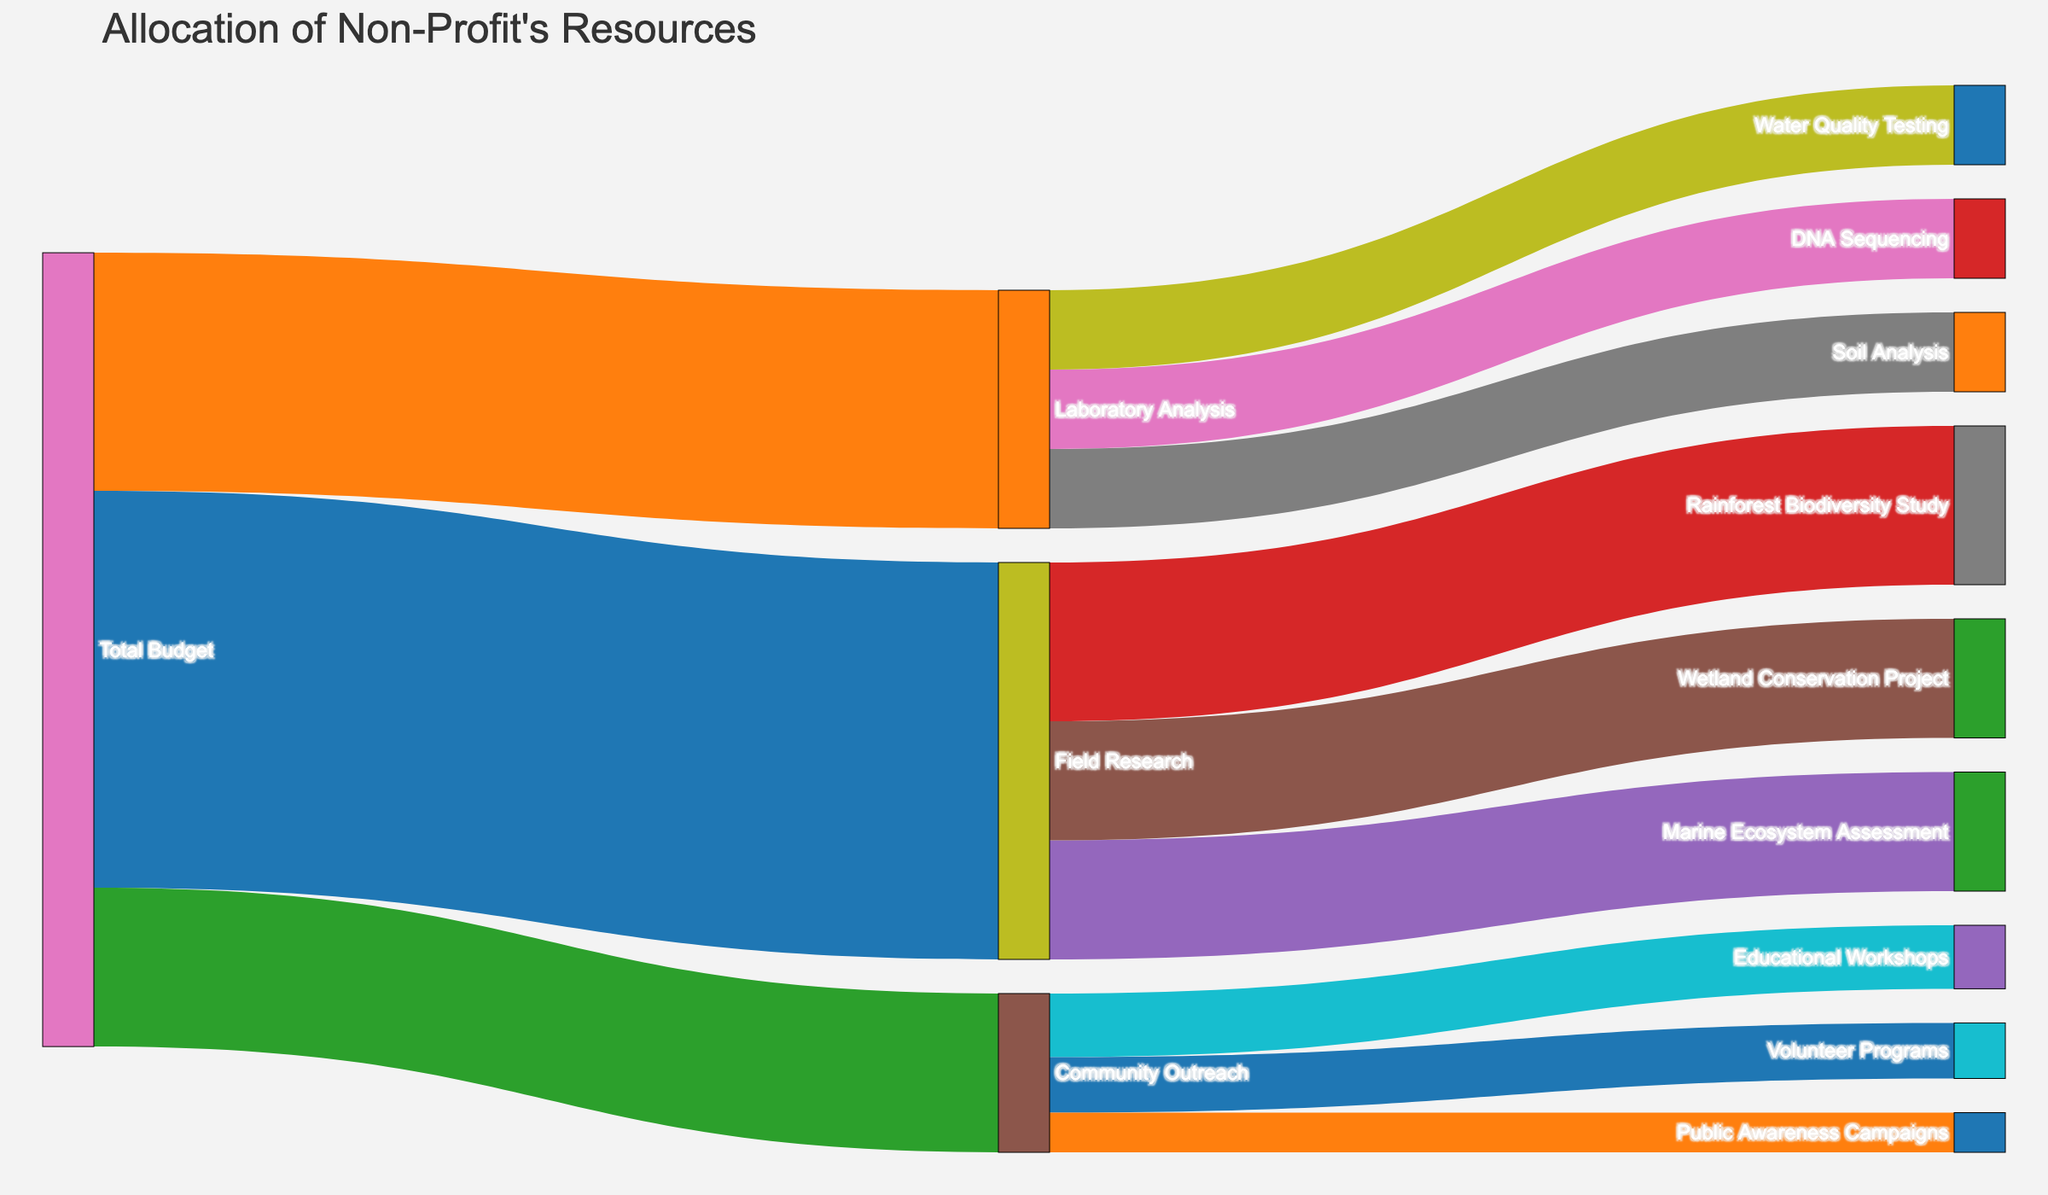What is the total budget allocated for field research? The figure shows that "Field Research" receives a portion of the "Total Budget." According to the diagram, the allocation for "Field Research" is 500,000.
Answer: 500,000 How much of the total budget is spent on Educational Workshops under Community Outreach? In the Sankey Diagram, under "Community Outreach," the stream leading to "Educational Workshops" is labeled with 80,000.
Answer: 80,000 Which initiative receives the highest funding within Field Research? The figure displays the breakdown under "Field Research." The streams from "Field Research" show "Rainforest Biodiversity Study" receives the highest funding of 200,000.
Answer: Rainforest Biodiversity Study How does the funding for Volunteer Programs compare to Public Awareness Campaigns within Community Outreach? Within "Community Outreach," the diagram shows that "Volunteer Programs" receive 70,000, while "Public Awareness Campaigns" receive 50,000.
Answer: Volunteer Programs receive 20,000 more What is the total amount allocated to community outreach programs? The sum of the streams under "Community Outreach" is the total allocation. Adding up for "Educational Workshops" (80,000), "Volunteer Programs" (70,000), and "Public Awareness Campaigns" (50,000) gives a total of 200,000.
Answer: 200,000 Which area of Laboratory Analysis receives the least funding? The Sankey Diagram indicates that DNA Sequencing, Soil Analysis, and Water Quality Testing each receive 100,000. Since they are equal, there's no single area that receives the least funding.
Answer: None, all receive equal funding How does the allocation for Marine Ecosystem Assessment compare with Wetland Conservation Project under Field Research? "Marine Ecosystem Assessment" receives 150,000, and "Wetland Conservation Project" also receives 150,000 according to the Sankey Diagram.
Answer: They receive equal funding What proportion of the total budget goes into Laboratory Analysis? The total budget allocated to "Laboratory Analysis" is 300,000 out of a total budget of 1,000,000. The proportion is 300,000/1,000,000 = 0.3 or 30%.
Answer: 30% How much funding is provided for DNA Sequencing, Soil Analysis, and Water Quality Testing combined within Laboratory Analysis? Adding the amounts for DNA Sequencing (100,000), Soil Analysis (100,000), and Water Quality Testing (100,000) gives a combined total of 300,000.
Answer: 300,000 Which initiative under Field Research has the smallest budget allocation? From the diagram, under "Field Research," both "Marine Ecosystem Assessment" and "Wetland Conservation Project" receive the same smallest amount of 150,000.
Answer: Marine Ecosystem Assessment and Wetland Conservation Project 